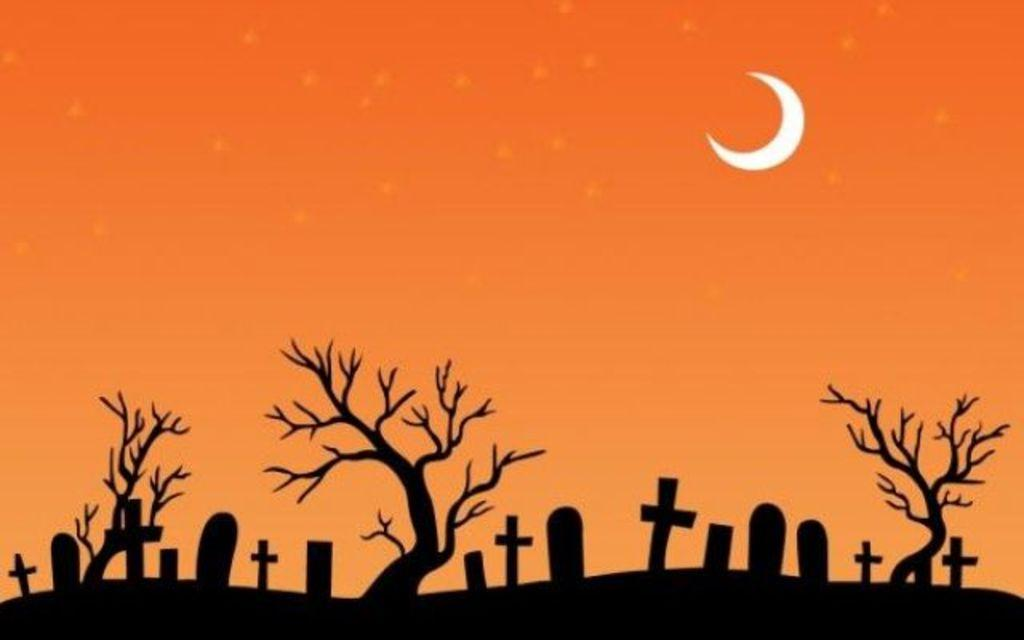What type of image is shown in the picture? The image is of a poster. What is depicted on the poster? There are trees and gravestones depicted on the poster. What can be seen in the background of the poster? The sky is visible in the background of the poster. How is the sky depicted in the poster? The sky has an orange color and the moon is visible in the sky. What type of friction can be observed between the trees and the earth in the image? There is no friction between the trees and the earth depicted in the image, as it is a poster and not a real-life scene. How does the poster help people start their day? The poster does not have any direct impact on starting someone's day; it is a visual representation of trees, gravestones, and the sky. 